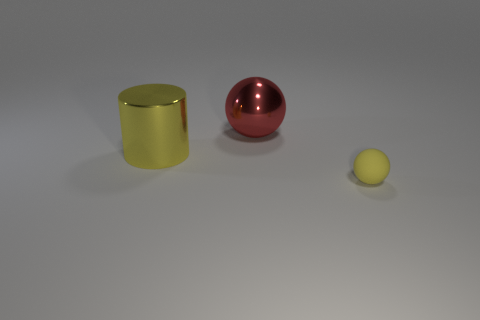Add 2 red cylinders. How many objects exist? 5 Subtract all spheres. How many objects are left? 1 Subtract 0 cyan cylinders. How many objects are left? 3 Subtract all big spheres. Subtract all large balls. How many objects are left? 1 Add 2 red metal objects. How many red metal objects are left? 3 Add 1 big cyan things. How many big cyan things exist? 1 